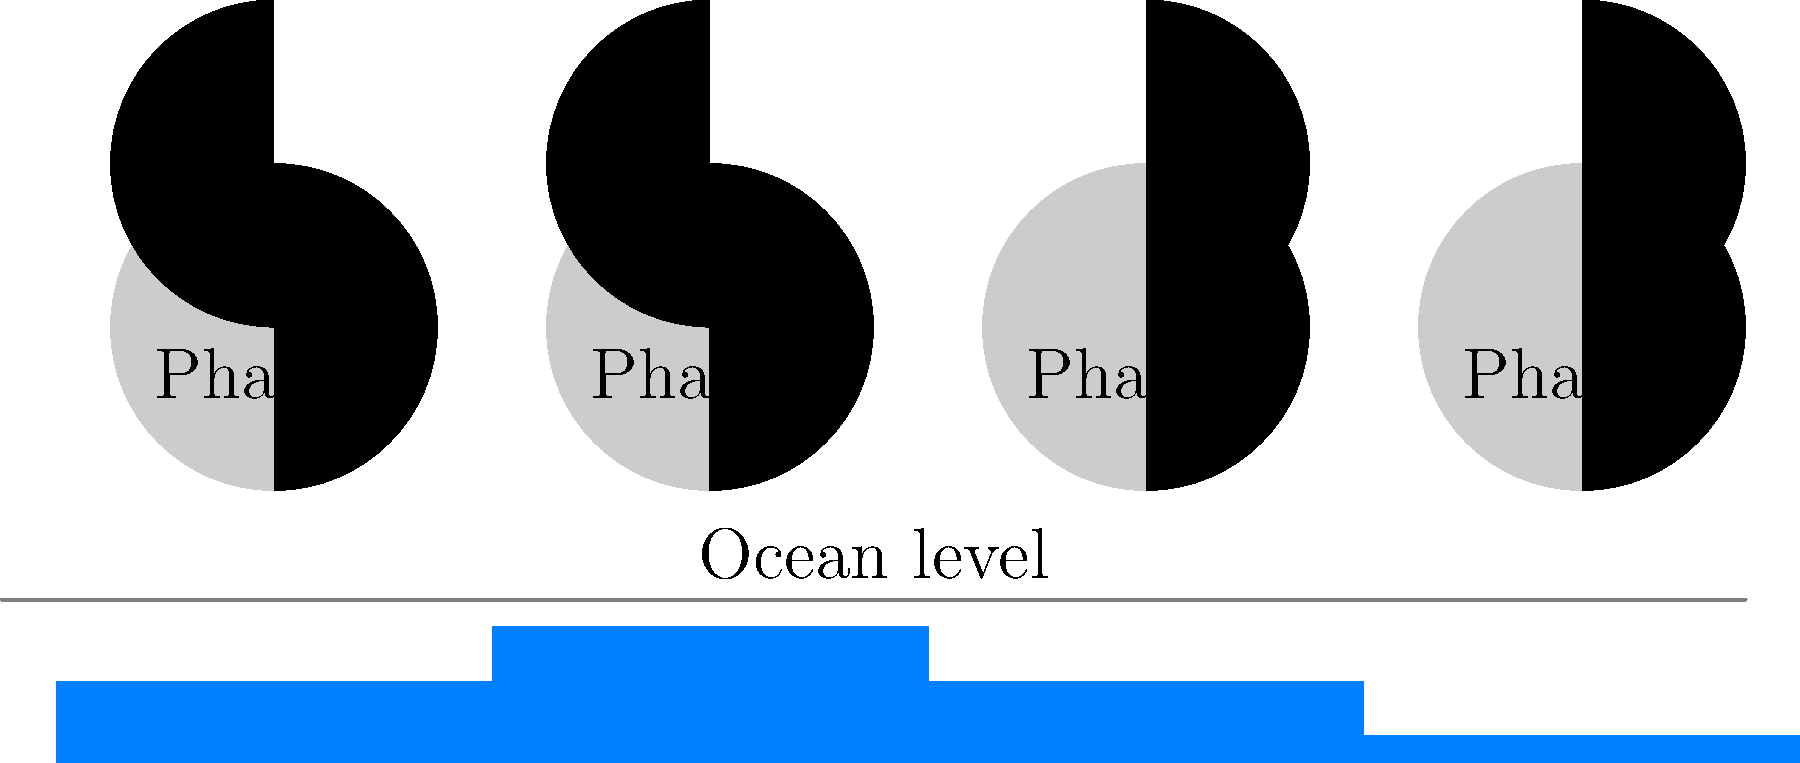As a navy veteran familiar with maritime operations, you understand the importance of tides. Examine the diagram showing four phases of the moon and corresponding ocean levels. Which phase of the moon corresponds to the highest tide, and why does this occur? Let's analyze this step-by-step:

1. The diagram shows four phases of the moon and their corresponding effect on ocean levels (tides).

2. The phases shown are:
   Phase 1: New Moon
   Phase 2: First Quarter
   Phase 3: Full Moon
   Phase 4: Last Quarter

3. We can observe that the highest tides occur during Phase 1 (New Moon) and Phase 3 (Full Moon).

4. This phenomenon is due to the gravitational forces of the moon and sun aligning:

   a) During a New Moon, the moon and sun are on the same side of Earth, combining their gravitational pull.
   
   b) During a Full Moon, the moon and sun are on opposite sides of Earth, again combining their gravitational pull.

5. These alignments create what we call "spring tides," which are the highest high tides and lowest low tides.

6. In contrast, during the First and Last Quarter phases (Phase 2 and 4), the moon and sun's gravitational forces are at right angles, partially canceling each other out. This results in lower high tides and higher low tides, known as "neap tides."

7. The gravitational effect of the moon is stronger than that of the sun due to its proximity to Earth, despite the sun's larger mass.

8. As a naval professional, understanding these tidal patterns is crucial for navigation, port operations, and coastal defense planning.
Answer: Phase 1 (New Moon) and Phase 3 (Full Moon); gravitational alignment of sun and moon 